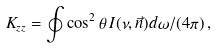<formula> <loc_0><loc_0><loc_500><loc_500>K _ { z z } = \oint \cos ^ { 2 } \theta \, I ( \nu , \vec { n } ) d \omega / ( 4 \pi ) \, ,</formula> 